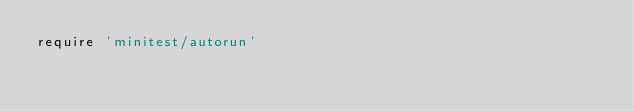<code> <loc_0><loc_0><loc_500><loc_500><_Ruby_>require 'minitest/autorun'
</code> 